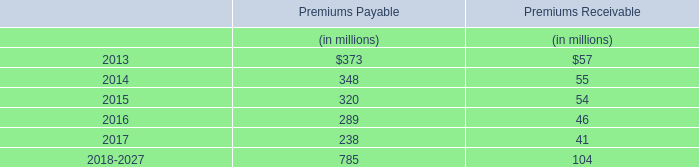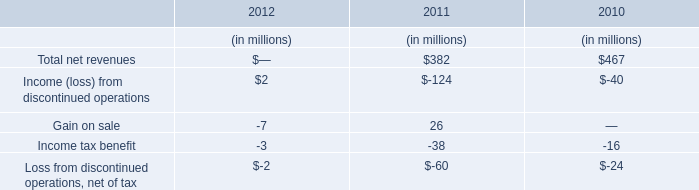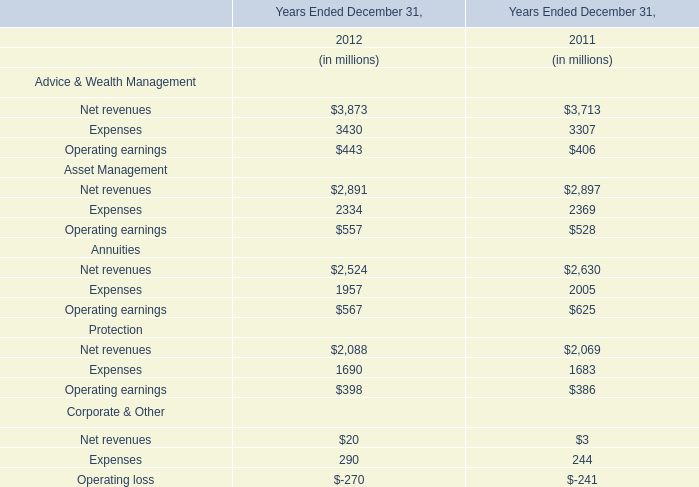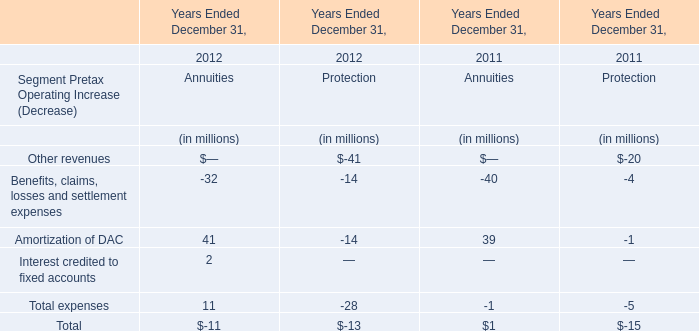What's the growth rate of Amortization of DAC of Annuities' Segment Pretax Operating in 2012? 
Computations: ((41 - 39) / 39)
Answer: 0.05128. 